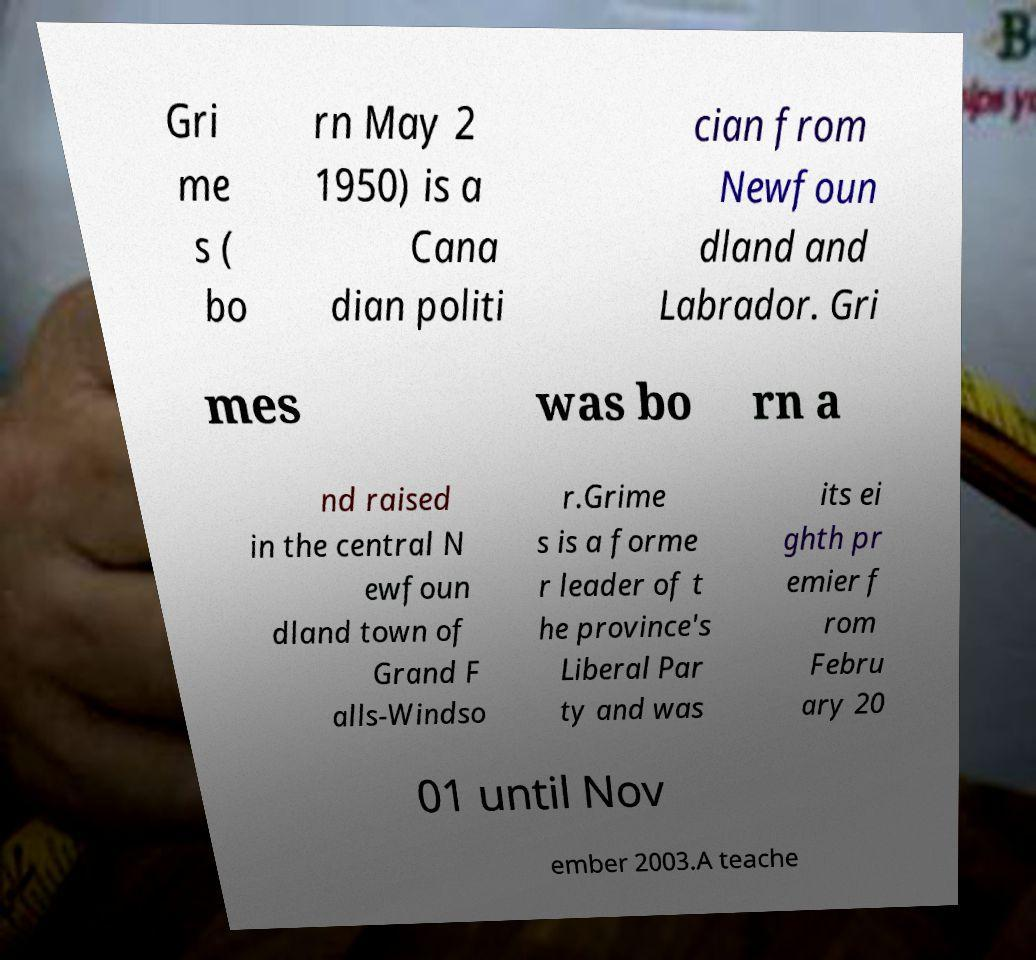Can you read and provide the text displayed in the image?This photo seems to have some interesting text. Can you extract and type it out for me? Gri me s ( bo rn May 2 1950) is a Cana dian politi cian from Newfoun dland and Labrador. Gri mes was bo rn a nd raised in the central N ewfoun dland town of Grand F alls-Windso r.Grime s is a forme r leader of t he province's Liberal Par ty and was its ei ghth pr emier f rom Febru ary 20 01 until Nov ember 2003.A teache 